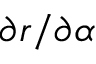<formula> <loc_0><loc_0><loc_500><loc_500>\partial r / \partial \alpha</formula> 